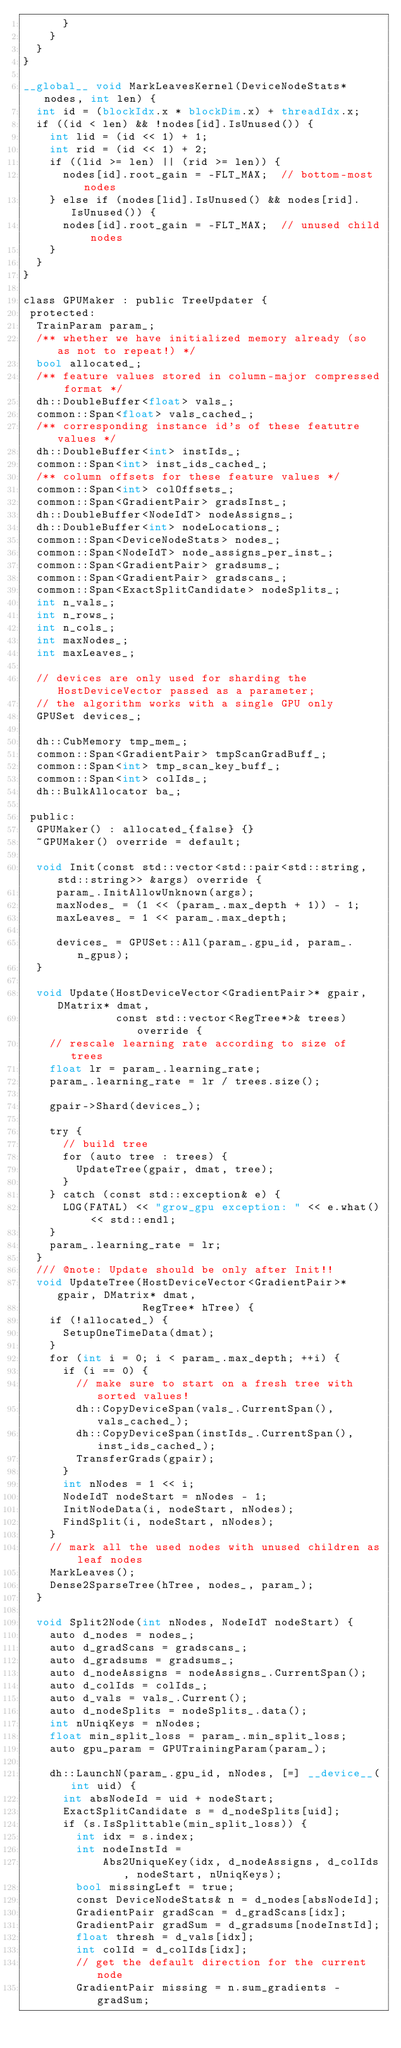<code> <loc_0><loc_0><loc_500><loc_500><_Cuda_>      }
    }
  }
}

__global__ void MarkLeavesKernel(DeviceNodeStats* nodes, int len) {
  int id = (blockIdx.x * blockDim.x) + threadIdx.x;
  if ((id < len) && !nodes[id].IsUnused()) {
    int lid = (id << 1) + 1;
    int rid = (id << 1) + 2;
    if ((lid >= len) || (rid >= len)) {
      nodes[id].root_gain = -FLT_MAX;  // bottom-most nodes
    } else if (nodes[lid].IsUnused() && nodes[rid].IsUnused()) {
      nodes[id].root_gain = -FLT_MAX;  // unused child nodes
    }
  }
}

class GPUMaker : public TreeUpdater {
 protected:
  TrainParam param_;
  /** whether we have initialized memory already (so as not to repeat!) */
  bool allocated_;
  /** feature values stored in column-major compressed format */
  dh::DoubleBuffer<float> vals_;
  common::Span<float> vals_cached_;
  /** corresponding instance id's of these featutre values */
  dh::DoubleBuffer<int> instIds_;
  common::Span<int> inst_ids_cached_;
  /** column offsets for these feature values */
  common::Span<int> colOffsets_;
  common::Span<GradientPair> gradsInst_;
  dh::DoubleBuffer<NodeIdT> nodeAssigns_;
  dh::DoubleBuffer<int> nodeLocations_;
  common::Span<DeviceNodeStats> nodes_;
  common::Span<NodeIdT> node_assigns_per_inst_;
  common::Span<GradientPair> gradsums_;
  common::Span<GradientPair> gradscans_;
  common::Span<ExactSplitCandidate> nodeSplits_;
  int n_vals_;
  int n_rows_;
  int n_cols_;
  int maxNodes_;
  int maxLeaves_;

  // devices are only used for sharding the HostDeviceVector passed as a parameter;
  // the algorithm works with a single GPU only
  GPUSet devices_;

  dh::CubMemory tmp_mem_;
  common::Span<GradientPair> tmpScanGradBuff_;
  common::Span<int> tmp_scan_key_buff_;
  common::Span<int> colIds_;
  dh::BulkAllocator ba_;

 public:
  GPUMaker() : allocated_{false} {}
  ~GPUMaker() override = default;

  void Init(const std::vector<std::pair<std::string, std::string>> &args) override {
     param_.InitAllowUnknown(args);
     maxNodes_ = (1 << (param_.max_depth + 1)) - 1;
     maxLeaves_ = 1 << param_.max_depth;

     devices_ = GPUSet::All(param_.gpu_id, param_.n_gpus);
  }

  void Update(HostDeviceVector<GradientPair>* gpair, DMatrix* dmat,
              const std::vector<RegTree*>& trees) override {
    // rescale learning rate according to size of trees
    float lr = param_.learning_rate;
    param_.learning_rate = lr / trees.size();

    gpair->Shard(devices_);

    try {
      // build tree
      for (auto tree : trees) {
        UpdateTree(gpair, dmat, tree);
      }
    } catch (const std::exception& e) {
      LOG(FATAL) << "grow_gpu exception: " << e.what() << std::endl;
    }
    param_.learning_rate = lr;
  }
  /// @note: Update should be only after Init!!
  void UpdateTree(HostDeviceVector<GradientPair>* gpair, DMatrix* dmat,
                  RegTree* hTree) {
    if (!allocated_) {
      SetupOneTimeData(dmat);
    }
    for (int i = 0; i < param_.max_depth; ++i) {
      if (i == 0) {
        // make sure to start on a fresh tree with sorted values!
        dh::CopyDeviceSpan(vals_.CurrentSpan(), vals_cached_);
        dh::CopyDeviceSpan(instIds_.CurrentSpan(), inst_ids_cached_);
        TransferGrads(gpair);
      }
      int nNodes = 1 << i;
      NodeIdT nodeStart = nNodes - 1;
      InitNodeData(i, nodeStart, nNodes);
      FindSplit(i, nodeStart, nNodes);
    }
    // mark all the used nodes with unused children as leaf nodes
    MarkLeaves();
    Dense2SparseTree(hTree, nodes_, param_);
  }

  void Split2Node(int nNodes, NodeIdT nodeStart) {
    auto d_nodes = nodes_;
    auto d_gradScans = gradscans_;
    auto d_gradsums = gradsums_;
    auto d_nodeAssigns = nodeAssigns_.CurrentSpan();
    auto d_colIds = colIds_;
    auto d_vals = vals_.Current();
    auto d_nodeSplits = nodeSplits_.data();
    int nUniqKeys = nNodes;
    float min_split_loss = param_.min_split_loss;
    auto gpu_param = GPUTrainingParam(param_);

    dh::LaunchN(param_.gpu_id, nNodes, [=] __device__(int uid) {
      int absNodeId = uid + nodeStart;
      ExactSplitCandidate s = d_nodeSplits[uid];
      if (s.IsSplittable(min_split_loss)) {
        int idx = s.index;
        int nodeInstId =
            Abs2UniqueKey(idx, d_nodeAssigns, d_colIds, nodeStart, nUniqKeys);
        bool missingLeft = true;
        const DeviceNodeStats& n = d_nodes[absNodeId];
        GradientPair gradScan = d_gradScans[idx];
        GradientPair gradSum = d_gradsums[nodeInstId];
        float thresh = d_vals[idx];
        int colId = d_colIds[idx];
        // get the default direction for the current node
        GradientPair missing = n.sum_gradients - gradSum;</code> 